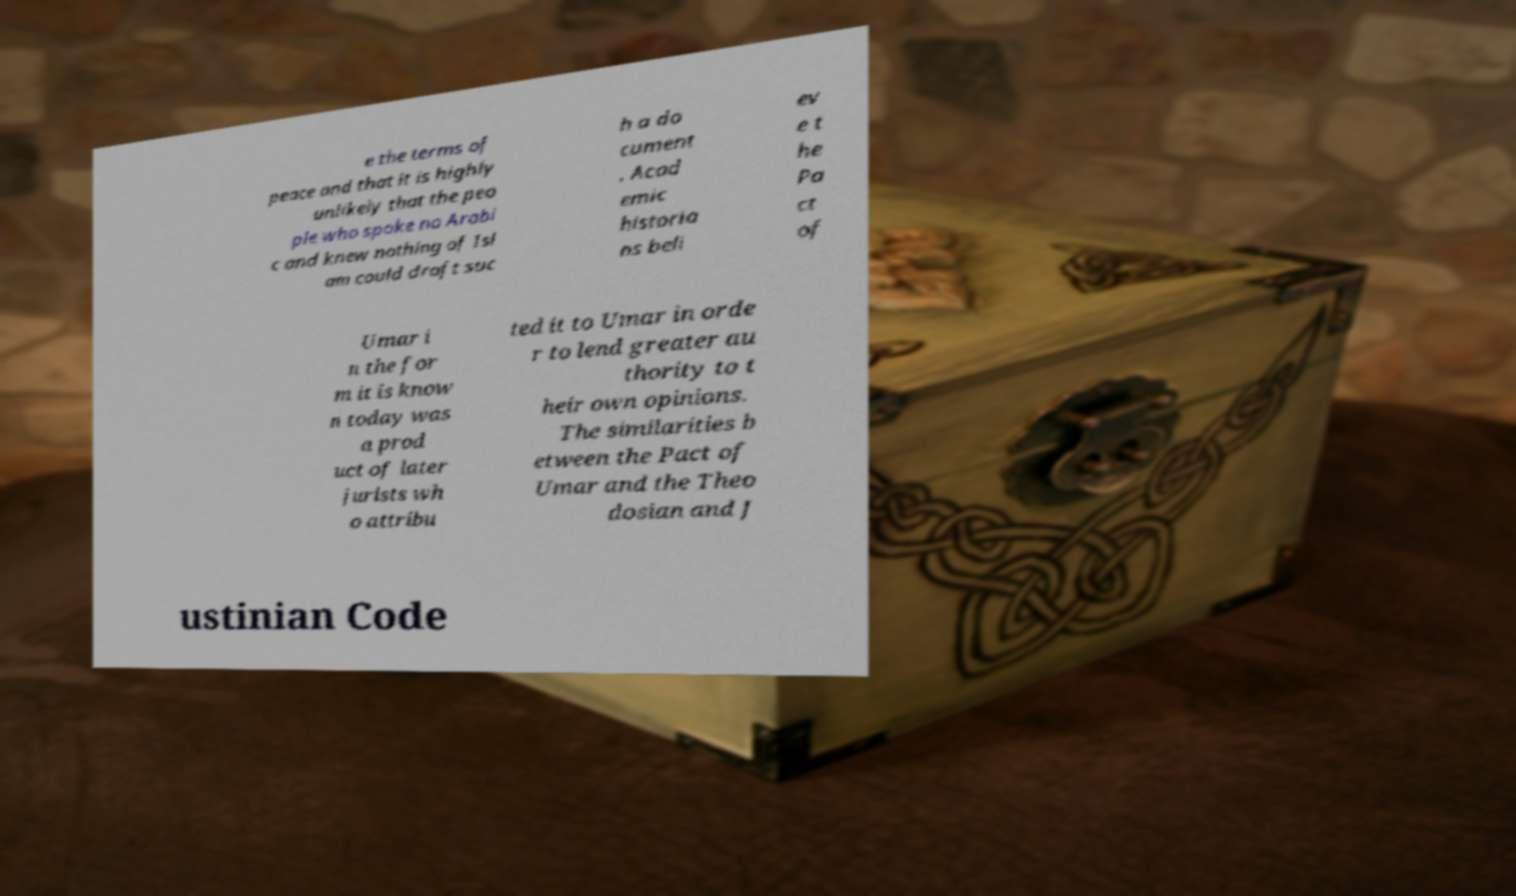There's text embedded in this image that I need extracted. Can you transcribe it verbatim? e the terms of peace and that it is highly unlikely that the peo ple who spoke no Arabi c and knew nothing of Isl am could draft suc h a do cument . Acad emic historia ns beli ev e t he Pa ct of Umar i n the for m it is know n today was a prod uct of later jurists wh o attribu ted it to Umar in orde r to lend greater au thority to t heir own opinions. The similarities b etween the Pact of Umar and the Theo dosian and J ustinian Code 